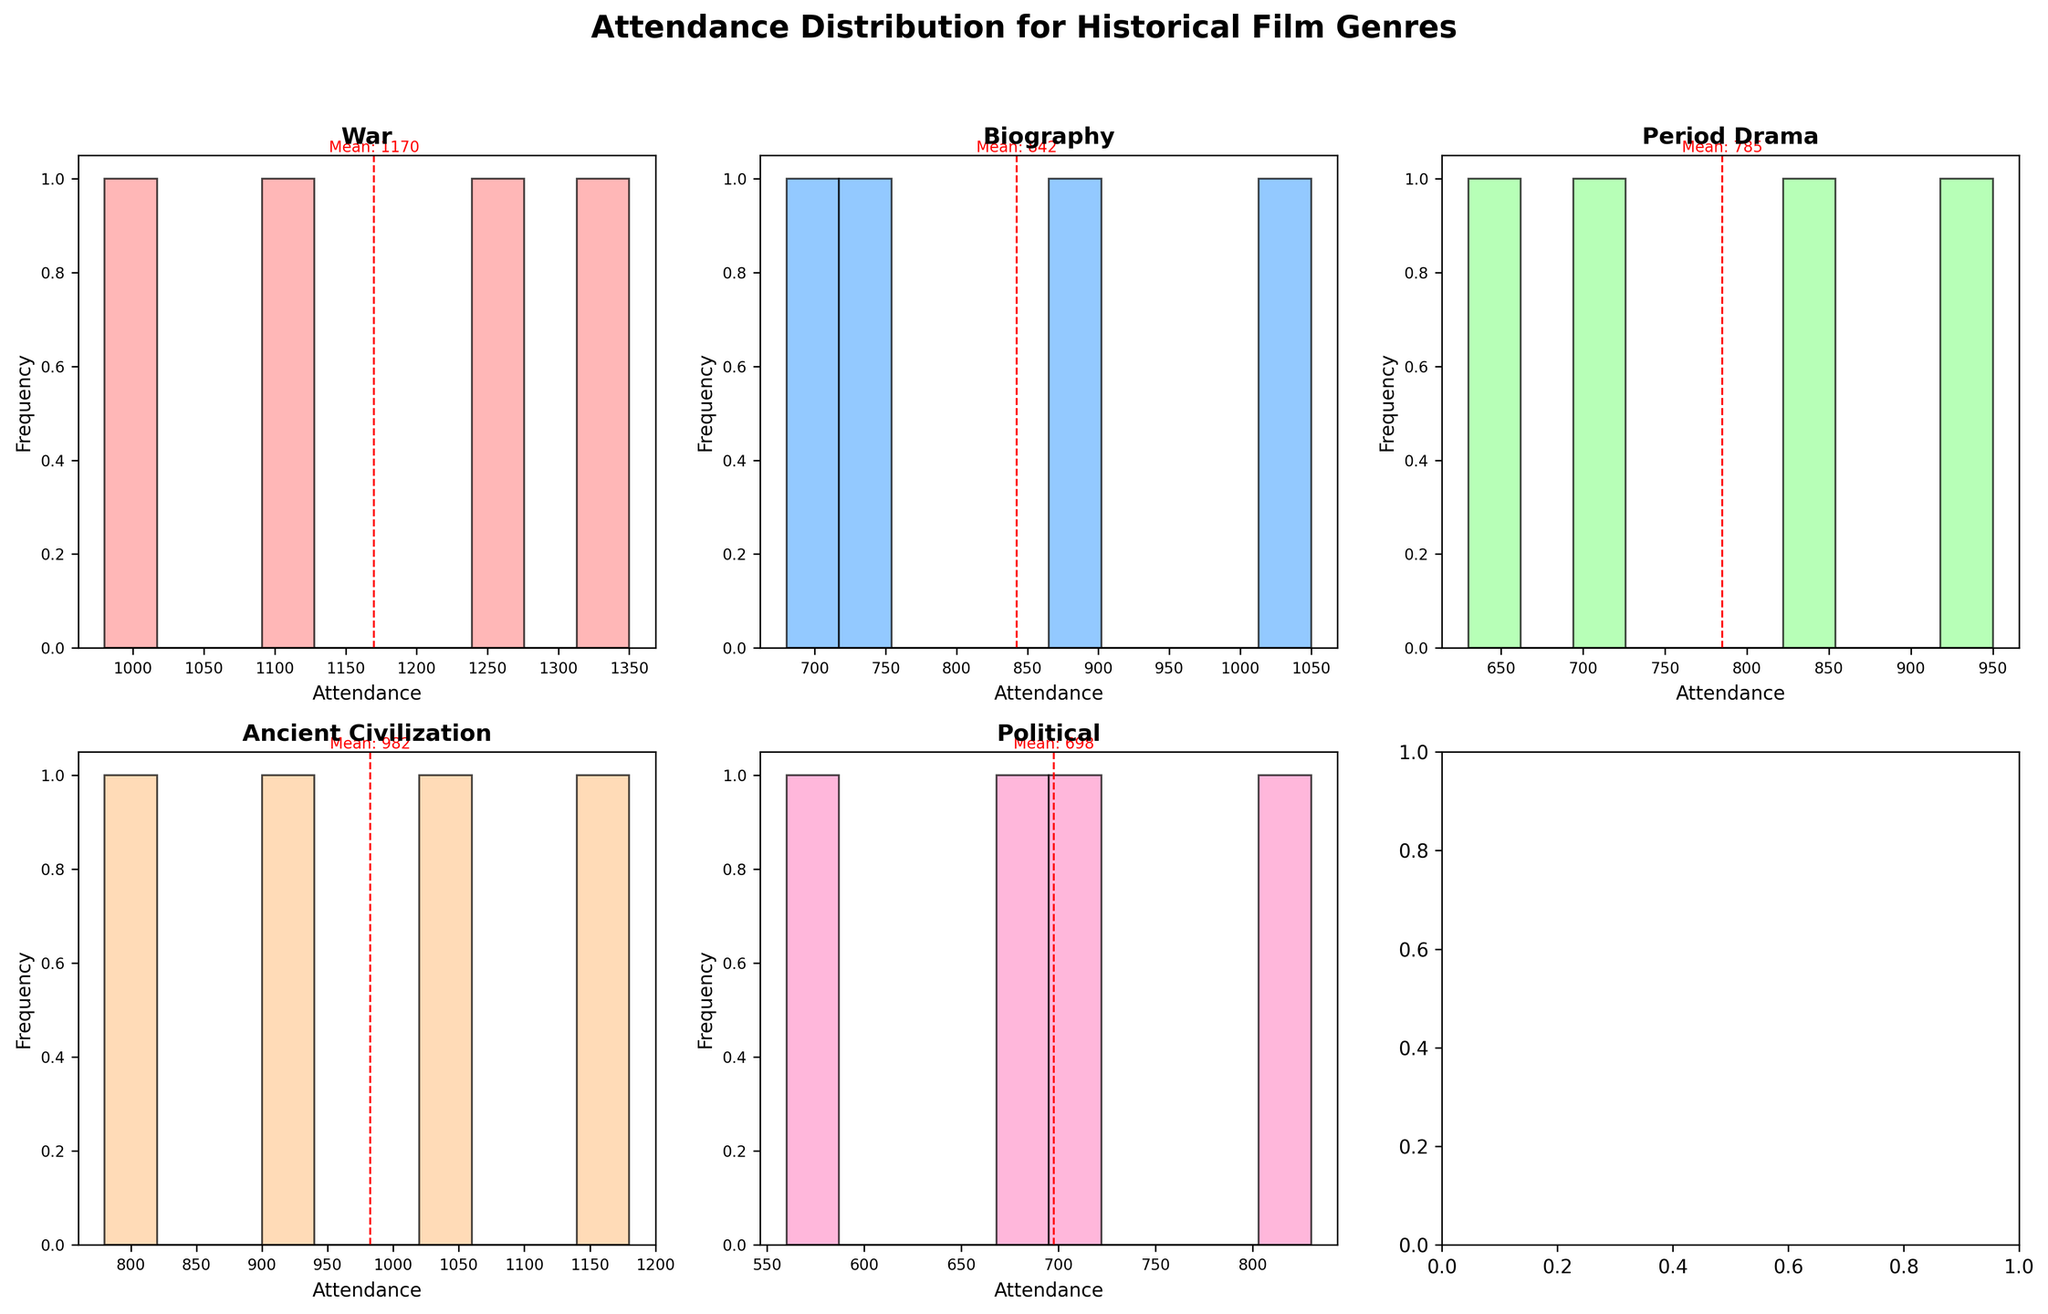Which genre has the highest mean attendance? The mean attendance lines are represented by red dashed lines in each subplot. The highest mean attendance can be identified by comparing these lines across subplots.
Answer: War What's the average attendance for Ancient Civilization films? First, sum the attendance for Gladiator (1180), Troy (920), 300 (1050), and Cleopatra (780), which equals 3930. Then, divide by the number of films (4).
Answer: 982.5 How many genres are represented in the histogram plots? Each subplot represents a different genre, and counting these gives the number of genres represented.
Answer: 5 Which genre has the lowest frequency of attendance between 500 and 700? Look at the height of the bars within the 500-700 attendance range for each subplot. The genre with the least bars in this range has the lowest frequency.
Answer: Political Is the attendance for "The Imitation Game" above or below the mean attendance for Biographies? Locate the red dashed line in the Biography subplot, representing the mean. Verify if 680 (attendance for "The Imitation Game") is above or below this line.
Answer: Below Which genre appears to have the most evenly distributed attendance values across its films? An evenly distributed set of attendance values will have a histogram with bars of roughly the same height. Compare this feature across different subplots.
Answer: Period Drama What is the mean attendance for the War genre? Sum the attendance values for Saving Private Ryan (1250), The Pianist (980), Dunkirk (1100), and 1917 (1350), resulting in 4680. Divide by the number of films (4).
Answer: 1170 Which genre has the film with the highest attendance, and what is that attendance? Identify the genre and attendance value of the tallest individual bar across all subplots.
Answer: War, 1350 How does the mean attendance of the Political genre compare to that of the Ancient Civilization genre? Calculate the mean attendance for each genre: Political (560 + 710 + 830 + 690)/4 = 697.5, and Ancient Civilization (1180 + 920 + 1050 + 780)/4 = 982.5. Compare the two mean values.
Answer: Political < Ancient Civilization 